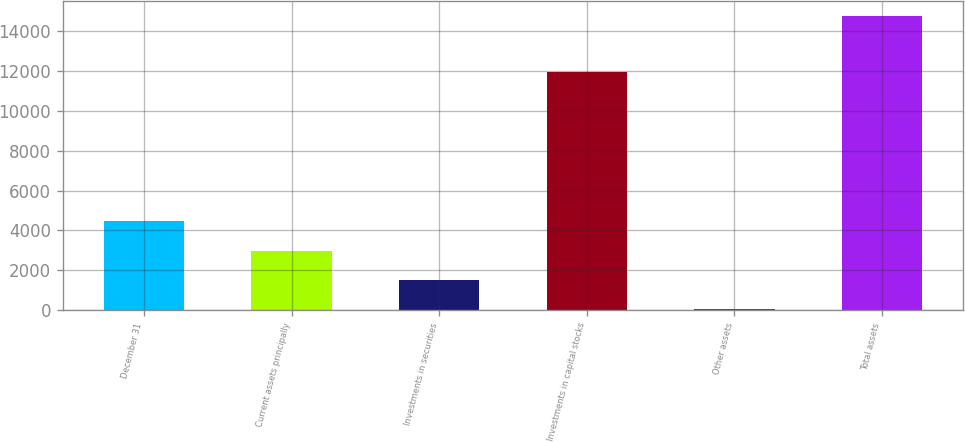Convert chart. <chart><loc_0><loc_0><loc_500><loc_500><bar_chart><fcel>December 31<fcel>Current assets principally<fcel>Investments in securities<fcel>Investments in capital stocks<fcel>Other assets<fcel>Total assets<nl><fcel>4446.3<fcel>2971.2<fcel>1496.1<fcel>11973<fcel>21<fcel>14772<nl></chart> 